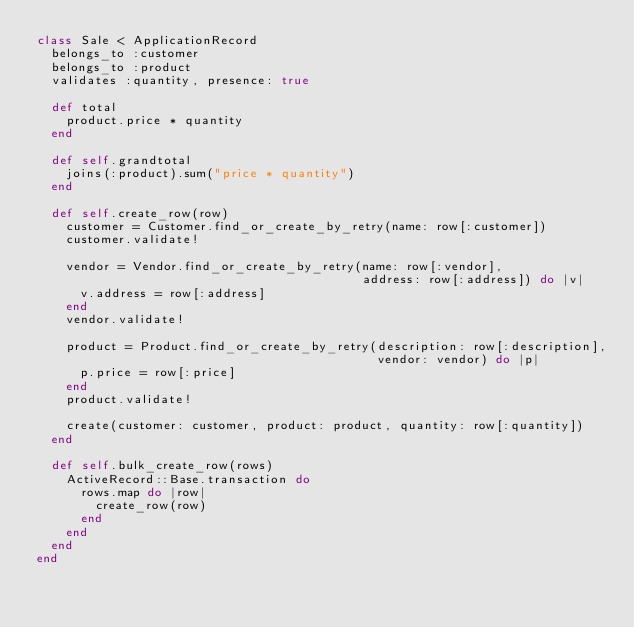Convert code to text. <code><loc_0><loc_0><loc_500><loc_500><_Ruby_>class Sale < ApplicationRecord
  belongs_to :customer
  belongs_to :product
  validates :quantity, presence: true

  def total
    product.price * quantity
  end

  def self.grandtotal
    joins(:product).sum("price * quantity")
  end

  def self.create_row(row)
    customer = Customer.find_or_create_by_retry(name: row[:customer])
    customer.validate!

    vendor = Vendor.find_or_create_by_retry(name: row[:vendor],
                                            address: row[:address]) do |v|
      v.address = row[:address]
    end
    vendor.validate!

    product = Product.find_or_create_by_retry(description: row[:description],
                                              vendor: vendor) do |p|
      p.price = row[:price]
    end
    product.validate!

    create(customer: customer, product: product, quantity: row[:quantity])
  end

  def self.bulk_create_row(rows)
    ActiveRecord::Base.transaction do
      rows.map do |row|
        create_row(row)
      end
    end
  end
end
</code> 